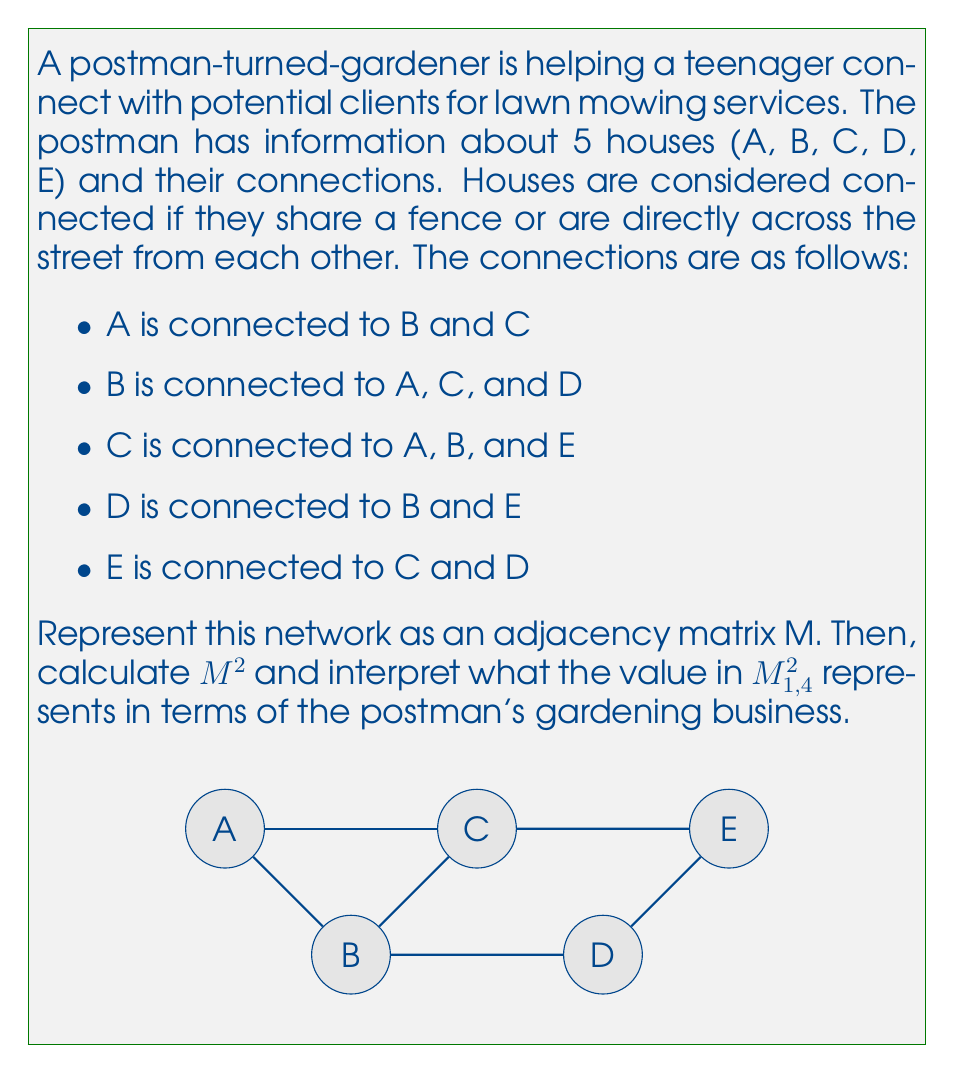Can you answer this question? Let's approach this step-by-step:

1) First, we need to create the adjacency matrix M. In an adjacency matrix, a 1 represents a connection between houses, and 0 represents no connection. The matrix will be 5x5 since we have 5 houses.

   $$M = \begin{bmatrix}
   0 & 1 & 1 & 0 & 0\\
   1 & 0 & 1 & 1 & 0\\
   1 & 1 & 0 & 0 & 1\\
   0 & 1 & 0 & 0 & 1\\
   0 & 0 & 1 & 1 & 0
   \end{bmatrix}$$

2) Now, we need to calculate $M^2$. This is done by multiplying M by itself:

   $$M^2 = \begin{bmatrix}
   0 & 1 & 1 & 0 & 0\\
   1 & 0 & 1 & 1 & 0\\
   1 & 1 & 0 & 0 & 1\\
   0 & 1 & 0 & 0 & 1\\
   0 & 0 & 1 & 1 & 0
   \end{bmatrix} \times 
   \begin{bmatrix}
   0 & 1 & 1 & 0 & 0\\
   1 & 0 & 1 & 1 & 0\\
   1 & 1 & 0 & 0 & 1\\
   0 & 1 & 0 & 0 & 1\\
   0 & 0 & 1 & 1 & 0
   \end{bmatrix}$$

3) After multiplication, we get:

   $$M^2 = \begin{bmatrix}
   2 & 1 & 1 & 1 & 1\\
   1 & 3 & 1 & 1 & 2\\
   1 & 1 & 3 & 2 & 1\\
   1 & 1 & 2 & 2 & 1\\
   1 & 2 & 1 & 1 & 2
   \end{bmatrix}$$

4) The value in $M^2_{1,4}$ is 1. This represents the number of 2-step paths between house A (row 1) and house D (column 4).

5) In terms of the postman's gardening business, this means there is exactly one way for the teenager to reach house D from house A in two steps. This could be useful for the postman to advise the teenager on efficient routes for offering services or for understanding the spread of word-of-mouth recommendations.

The path is A → B → D, which the postman could suggest as an efficient route for the teenager to offer services to houses A, B, and D in one trip.
Answer: 1; represents one 2-step path from A to D 